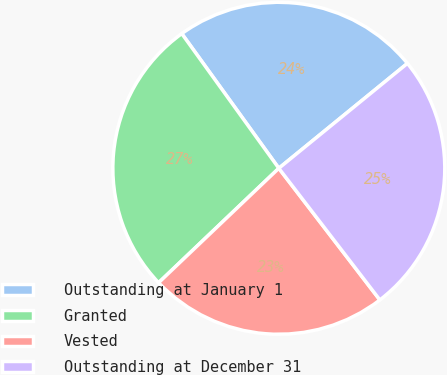Convert chart. <chart><loc_0><loc_0><loc_500><loc_500><pie_chart><fcel>Outstanding at January 1<fcel>Granted<fcel>Vested<fcel>Outstanding at December 31<nl><fcel>24.05%<fcel>27.17%<fcel>23.31%<fcel>25.47%<nl></chart> 